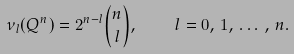Convert formula to latex. <formula><loc_0><loc_0><loc_500><loc_500>\nu _ { l } ( Q ^ { n } ) = 2 ^ { n - l } \binom { n } { l } , \quad l = 0 , \, 1 , \, \dots \, , \, n .</formula> 